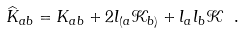<formula> <loc_0><loc_0><loc_500><loc_500>\widehat { K } _ { a b } = K _ { a b } + 2 l _ { ( a } \mathcal { K } _ { b ) } + l _ { a } l _ { b } \mathcal { K \ } .</formula> 